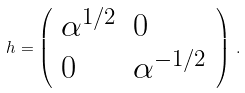Convert formula to latex. <formula><loc_0><loc_0><loc_500><loc_500>h = \left ( \begin{array} { l l } \alpha ^ { 1 / 2 } & 0 \\ 0 & \alpha ^ { - 1 / 2 } \end{array} \right ) \, .</formula> 